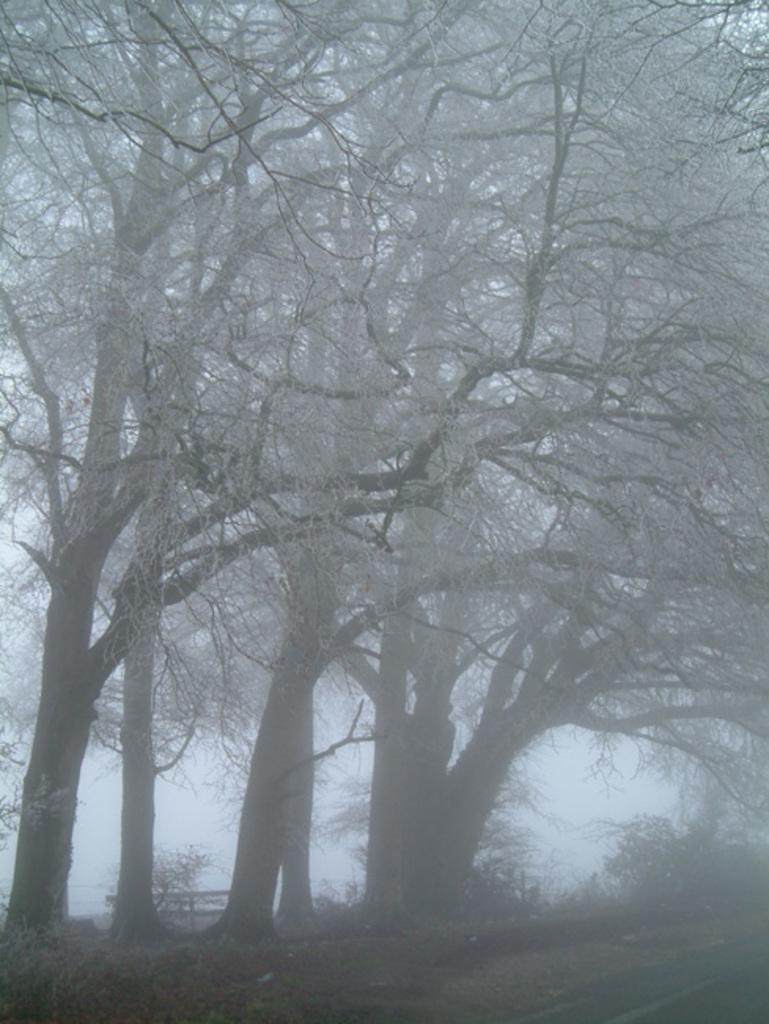What type of natural vegetation can be seen in the image? There are trees in the image. What man-made structure is visible on the bottom right side of the image? There is a road on the bottom right side of the image. Can you describe the seating arrangement in the image? There appears to be a wooden bench between the trees in the image. What type of cream is being used to improve the memory of the mom in the image? There is no mention of cream, memory, or mom in the image; the image only features trees, a road, and a wooden bench. 